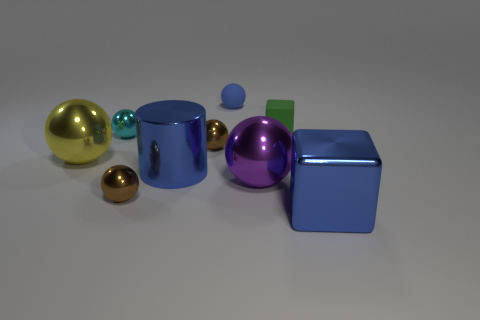Subtract all metal spheres. How many spheres are left? 1 Subtract all blue cubes. How many cubes are left? 1 Subtract all balls. How many objects are left? 3 Add 1 tiny brown balls. How many objects exist? 10 Subtract all yellow spheres. How many blue cubes are left? 1 Subtract all small blue matte spheres. Subtract all green rubber blocks. How many objects are left? 7 Add 9 purple metal things. How many purple metal things are left? 10 Add 7 green matte cylinders. How many green matte cylinders exist? 7 Subtract 1 purple balls. How many objects are left? 8 Subtract 1 cubes. How many cubes are left? 1 